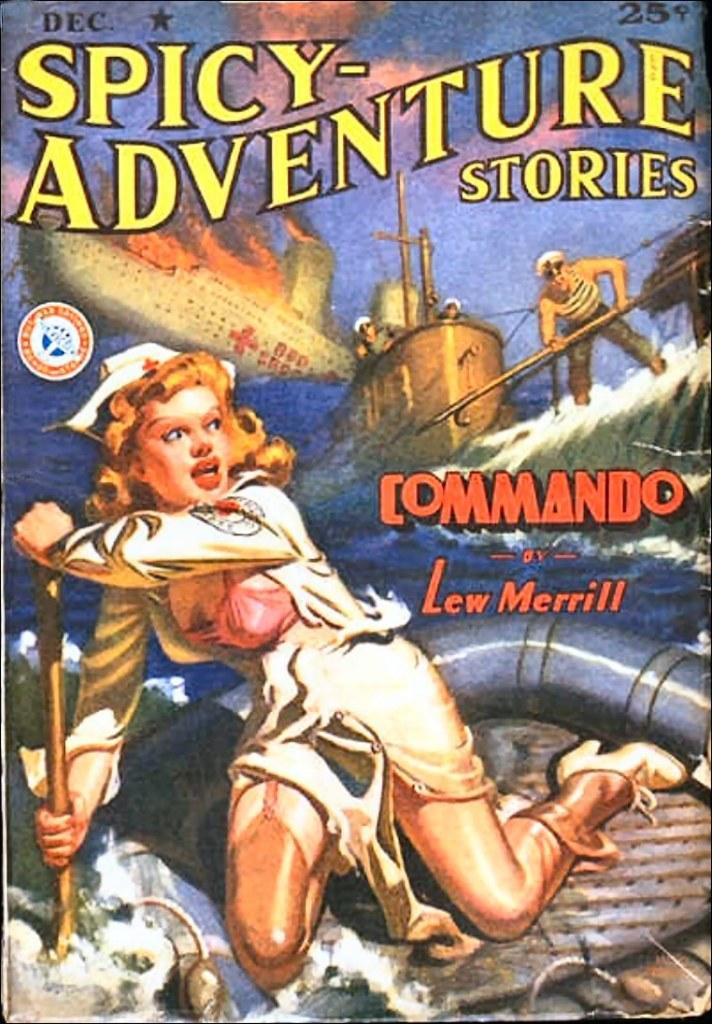Provide a one-sentence caption for the provided image. a cover of the book spicy adventure stories written by Lew Merril. 